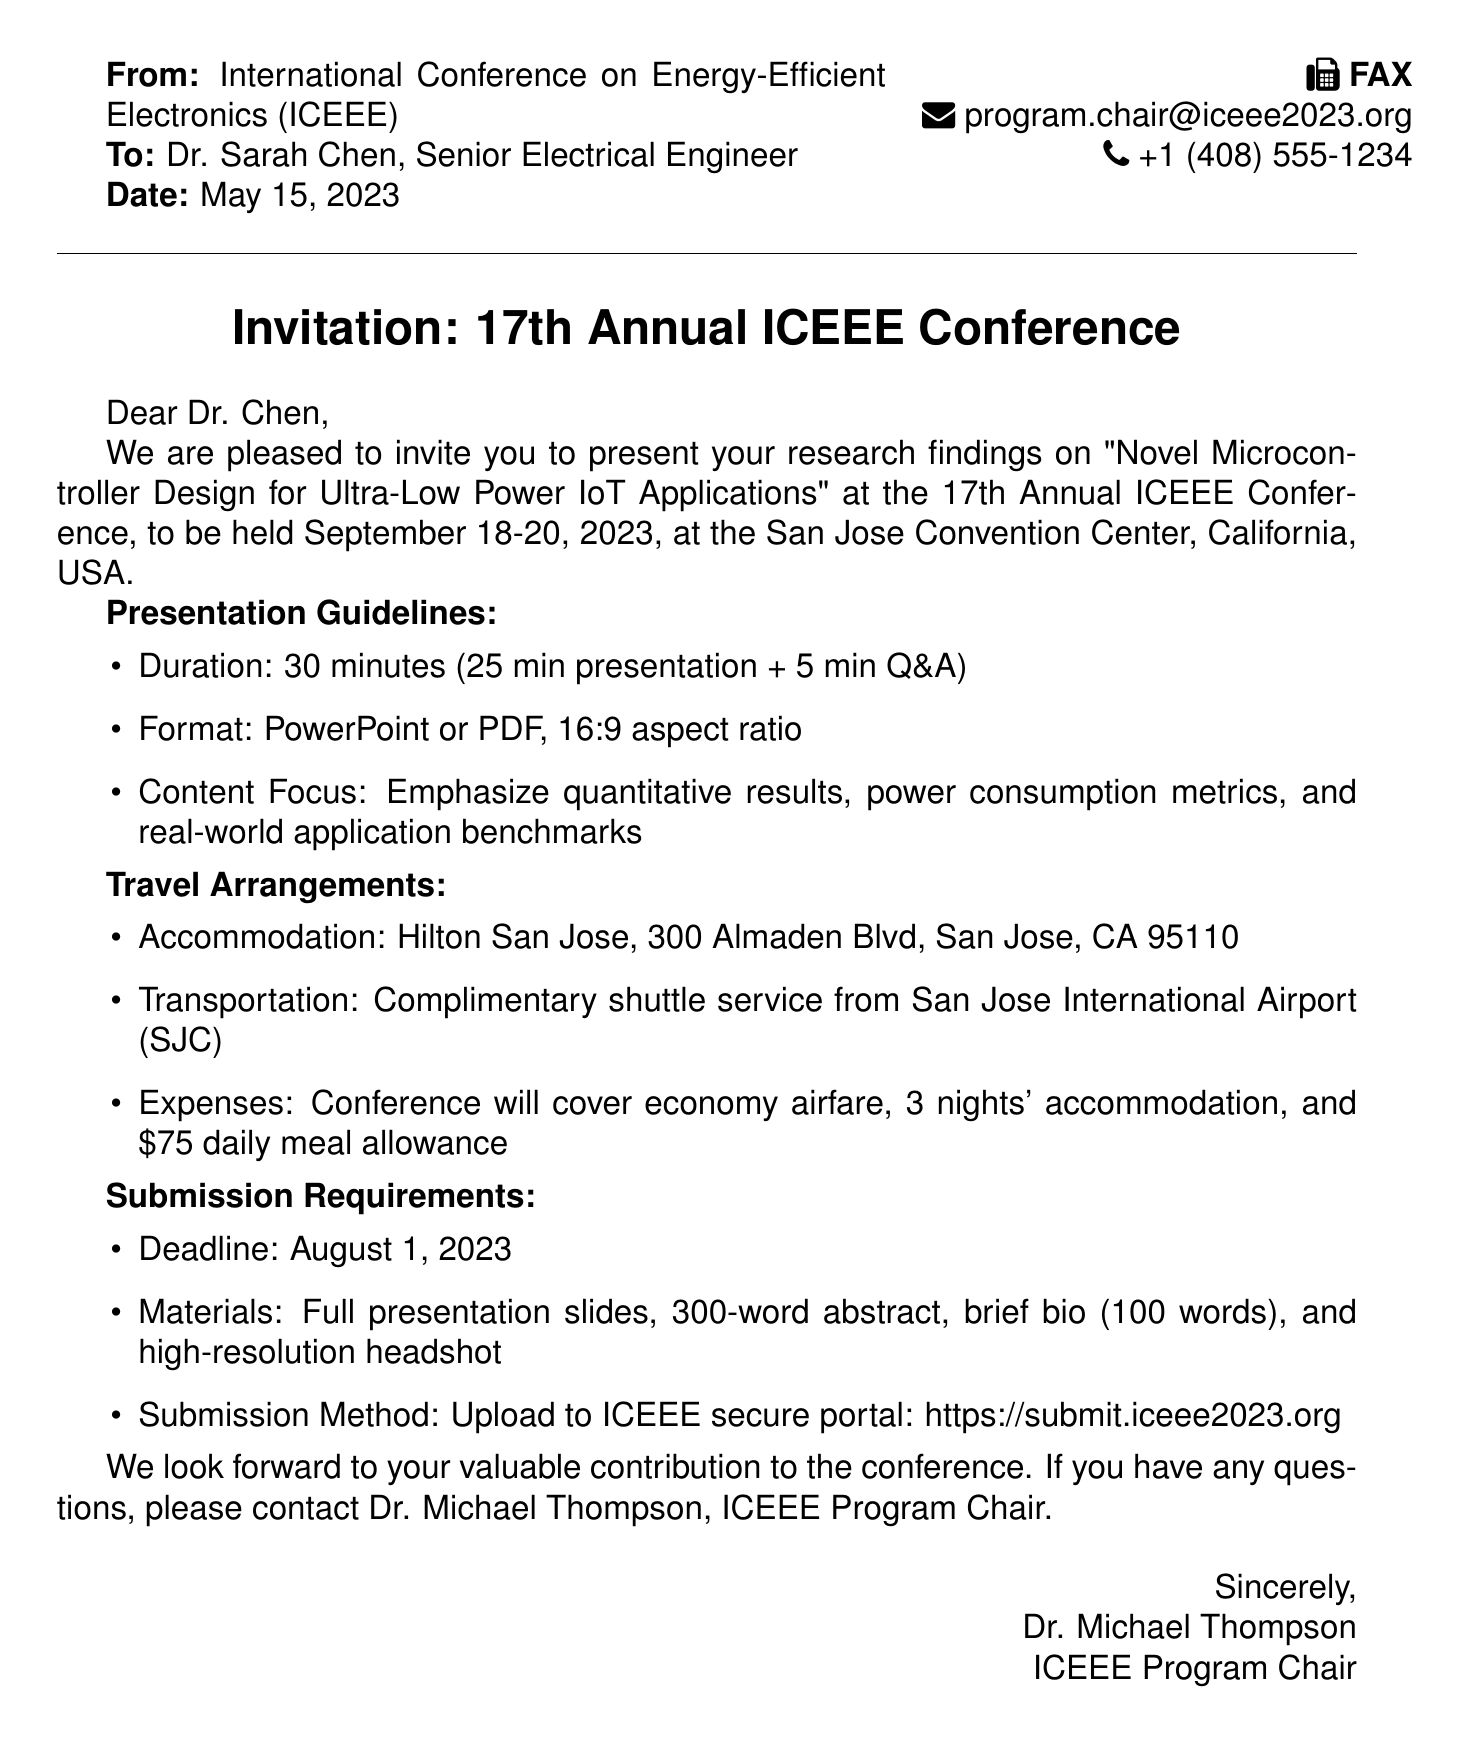what is the title of the research findings to be presented? The title is stated in the invitation section of the document.
Answer: Novel Microcontroller Design for Ultra-Low Power IoT Applications what are the dates of the conference? The dates are mentioned in the invitation section of the document.
Answer: September 18-20, 2023 what is the presentation duration? The duration is specified in the presentation guidelines.
Answer: 30 minutes who is the Program Chair of the conference? The Program Chair's name is provided at the end of the document.
Answer: Dr. Michael Thompson what is the submission deadline for presentation materials? The deadline is indicated in the submission requirements section.
Answer: August 1, 2023 what is the daily meal allowance provided by the conference? The amount is listed under travel arrangements.
Answer: $75 what format should the presentation be in? The required format is specified in the presentation guidelines.
Answer: PowerPoint or PDF what type of transportation is provided from the airport? The transportation details are included in the travel arrangements.
Answer: Complimentary shuttle service what is required along with the full presentation slides for submission? Additional requirements are listed in the submission requirements section.
Answer: 300-word abstract, brief bio, and high-resolution headshot 